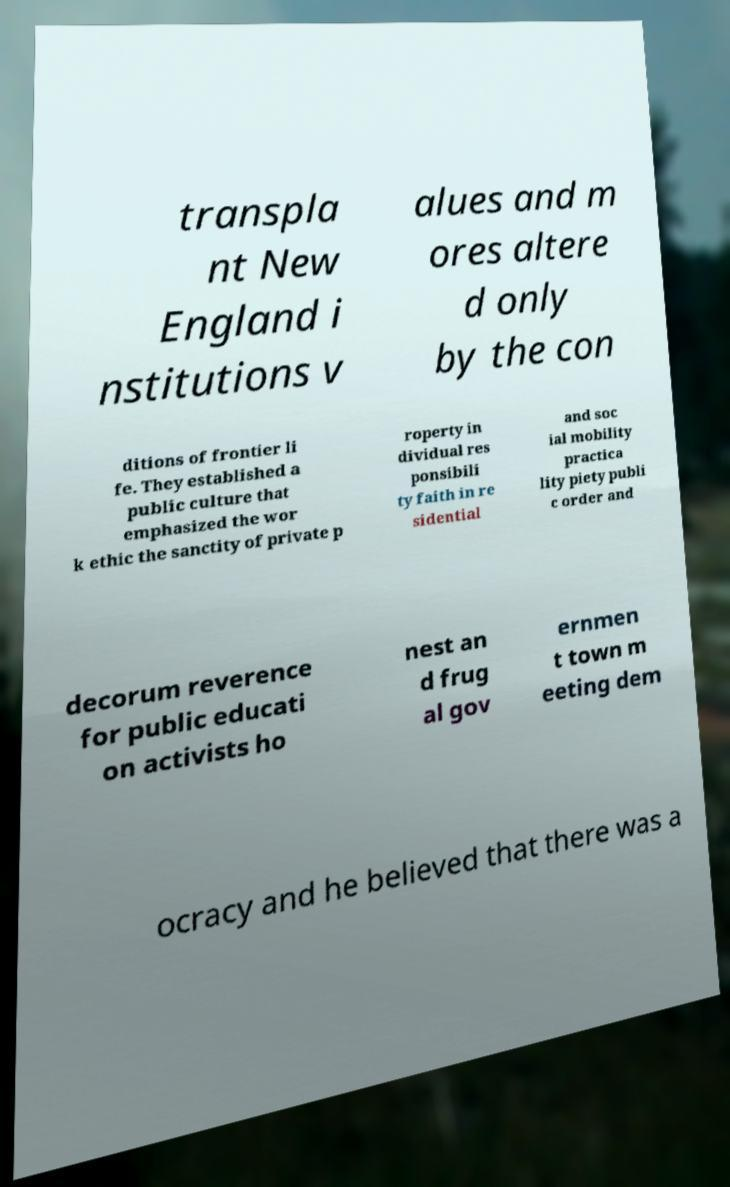There's text embedded in this image that I need extracted. Can you transcribe it verbatim? transpla nt New England i nstitutions v alues and m ores altere d only by the con ditions of frontier li fe. They established a public culture that emphasized the wor k ethic the sanctity of private p roperty in dividual res ponsibili ty faith in re sidential and soc ial mobility practica lity piety publi c order and decorum reverence for public educati on activists ho nest an d frug al gov ernmen t town m eeting dem ocracy and he believed that there was a 